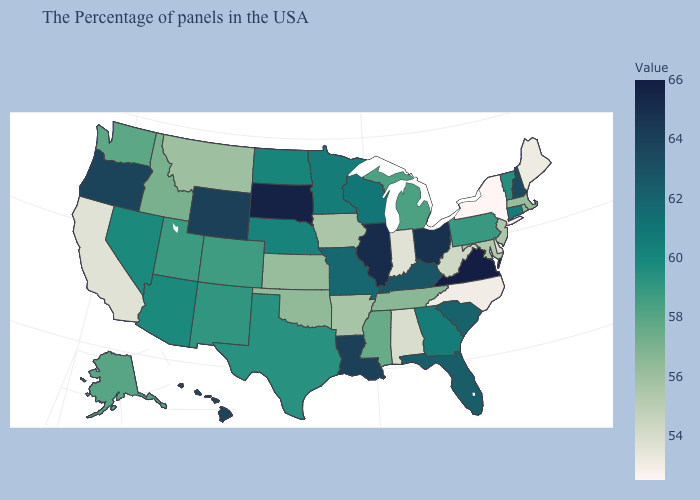Does New York have the lowest value in the USA?
Give a very brief answer. Yes. Which states have the lowest value in the West?
Answer briefly. California. Which states have the lowest value in the MidWest?
Concise answer only. Indiana. Does Texas have the highest value in the South?
Short answer required. No. Among the states that border Georgia , does Florida have the highest value?
Keep it brief. Yes. Among the states that border Illinois , which have the lowest value?
Quick response, please. Indiana. Does New Mexico have a higher value than Indiana?
Concise answer only. Yes. 